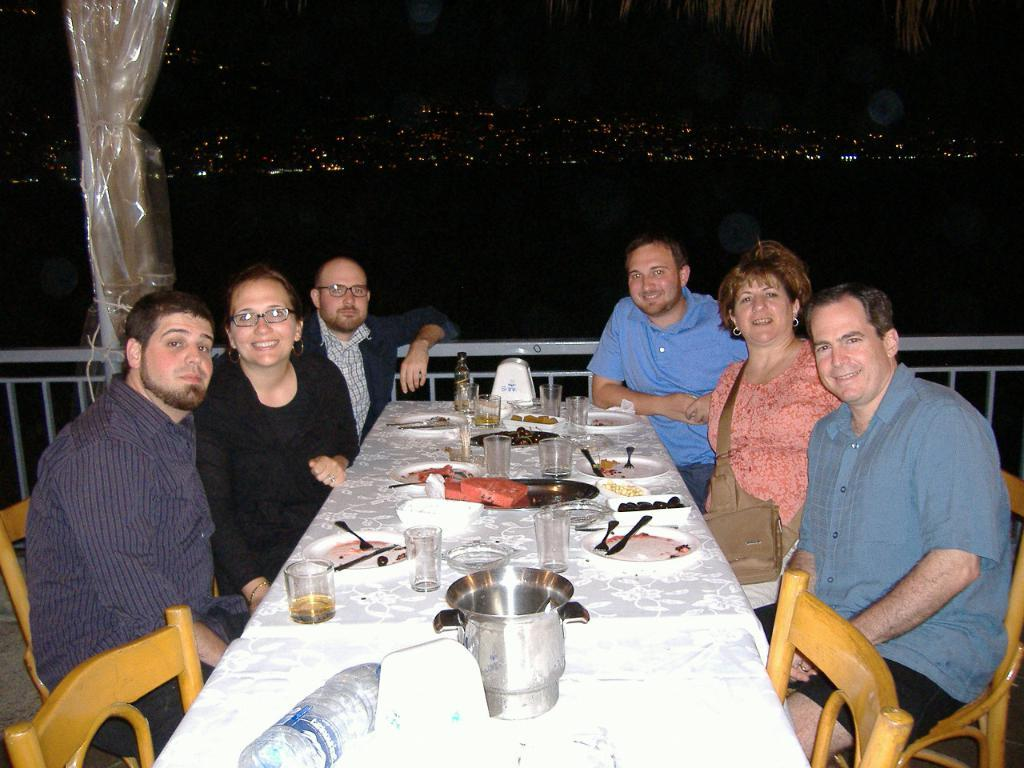How many people are in the image? There are six people in the image. How many of them are women? Two of the people are women. How many of them are men? Four of the people are men. What are the people doing in the image? The people are sitting in chairs. Where are the chairs located in relation to the table? The chairs are behind the table. What objects can be seen on the table? There is a glass, a water bottle, a jar, a plate, a spoon, and a tray on the table. What is on the table besides these objects? There is food on the table. What type of van can be seen parked outside the window in the image? There is no van visible in the image, as it only shows people sitting behind a table with various objects. 